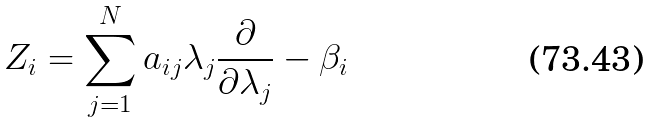<formula> <loc_0><loc_0><loc_500><loc_500>Z _ { i } = \sum _ { j = 1 } ^ { N } a _ { i j } \lambda _ { j } \frac { \partial } { \partial \lambda _ { j } } - \beta _ { i } \quad</formula> 